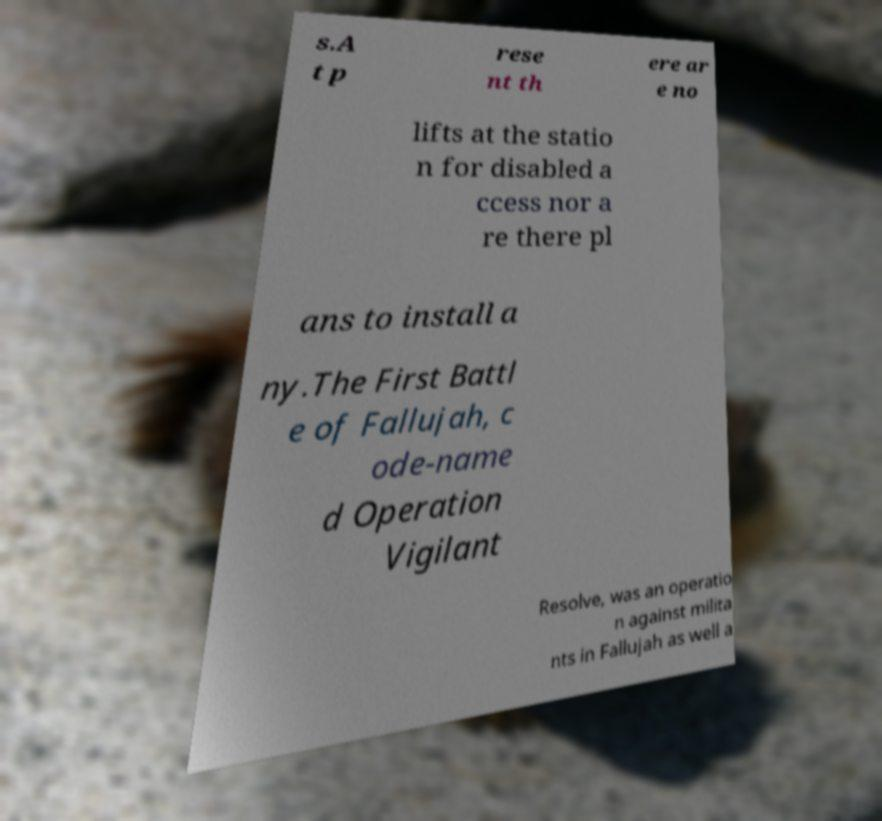Could you assist in decoding the text presented in this image and type it out clearly? s.A t p rese nt th ere ar e no lifts at the statio n for disabled a ccess nor a re there pl ans to install a ny.The First Battl e of Fallujah, c ode-name d Operation Vigilant Resolve, was an operatio n against milita nts in Fallujah as well a 